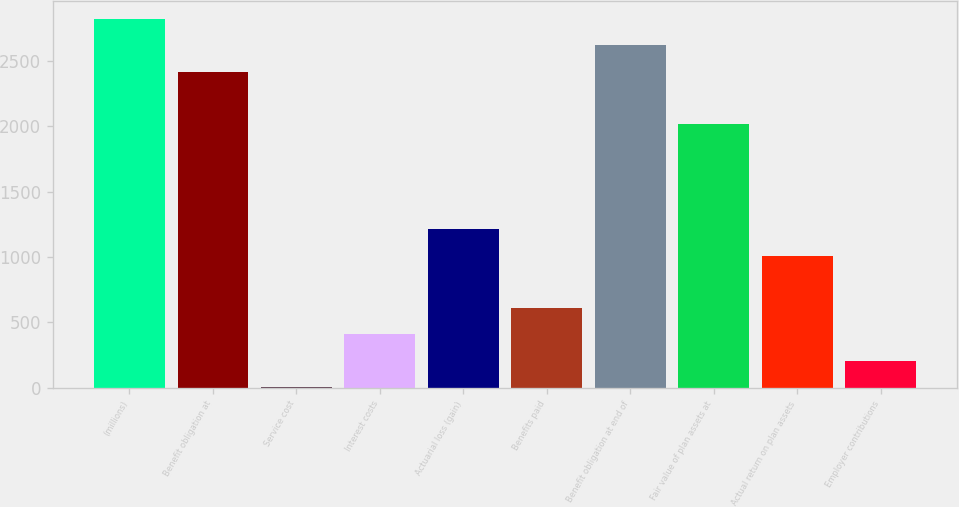Convert chart. <chart><loc_0><loc_0><loc_500><loc_500><bar_chart><fcel>(millions)<fcel>Benefit obligation at<fcel>Service cost<fcel>Interest costs<fcel>Actuarial loss (gain)<fcel>Benefits paid<fcel>Benefit obligation at end of<fcel>Fair value of plan assets at<fcel>Actual return on plan assets<fcel>Employer contributions<nl><fcel>2819.56<fcel>2417.78<fcel>7.1<fcel>408.88<fcel>1212.44<fcel>609.77<fcel>2618.67<fcel>2016<fcel>1011.55<fcel>207.99<nl></chart> 